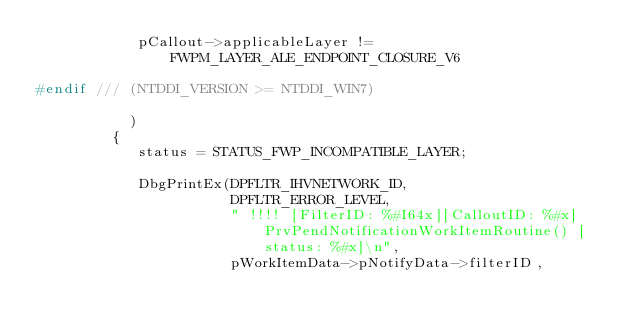<code> <loc_0><loc_0><loc_500><loc_500><_C++_>            pCallout->applicableLayer != FWPM_LAYER_ALE_ENDPOINT_CLOSURE_V6

#endif /// (NTDDI_VERSION >= NTDDI_WIN7)

           )
         {
            status = STATUS_FWP_INCOMPATIBLE_LAYER;

            DbgPrintEx(DPFLTR_IHVNETWORK_ID,
                       DPFLTR_ERROR_LEVEL,
                       " !!!! [FilterID: %#I64x][CalloutID: %#x] PrvPendNotificationWorkItemRoutine() [status: %#x]\n",
                       pWorkItemData->pNotifyData->filterID,</code> 